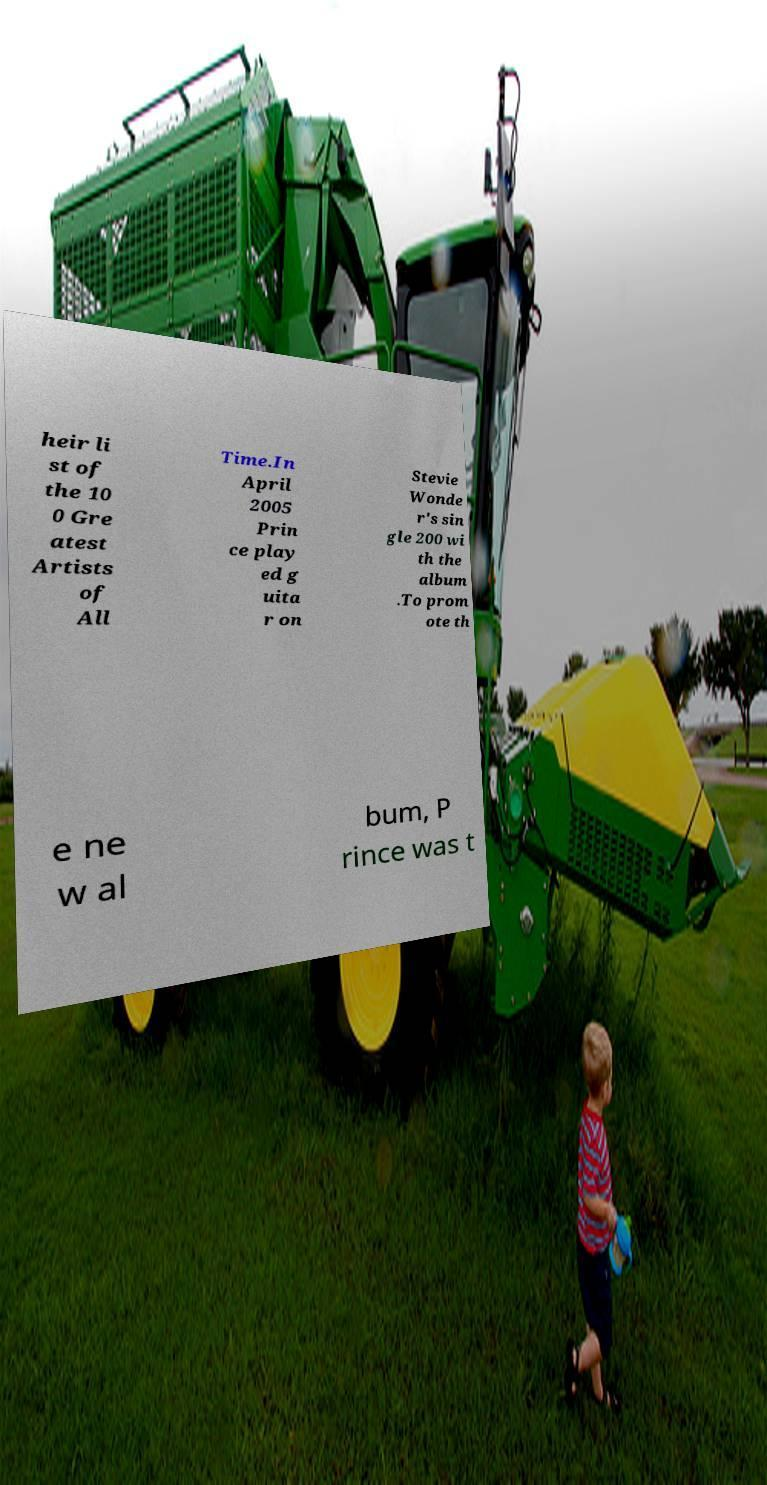Please read and relay the text visible in this image. What does it say? heir li st of the 10 0 Gre atest Artists of All Time.In April 2005 Prin ce play ed g uita r on Stevie Wonde r's sin gle 200 wi th the album .To prom ote th e ne w al bum, P rince was t 